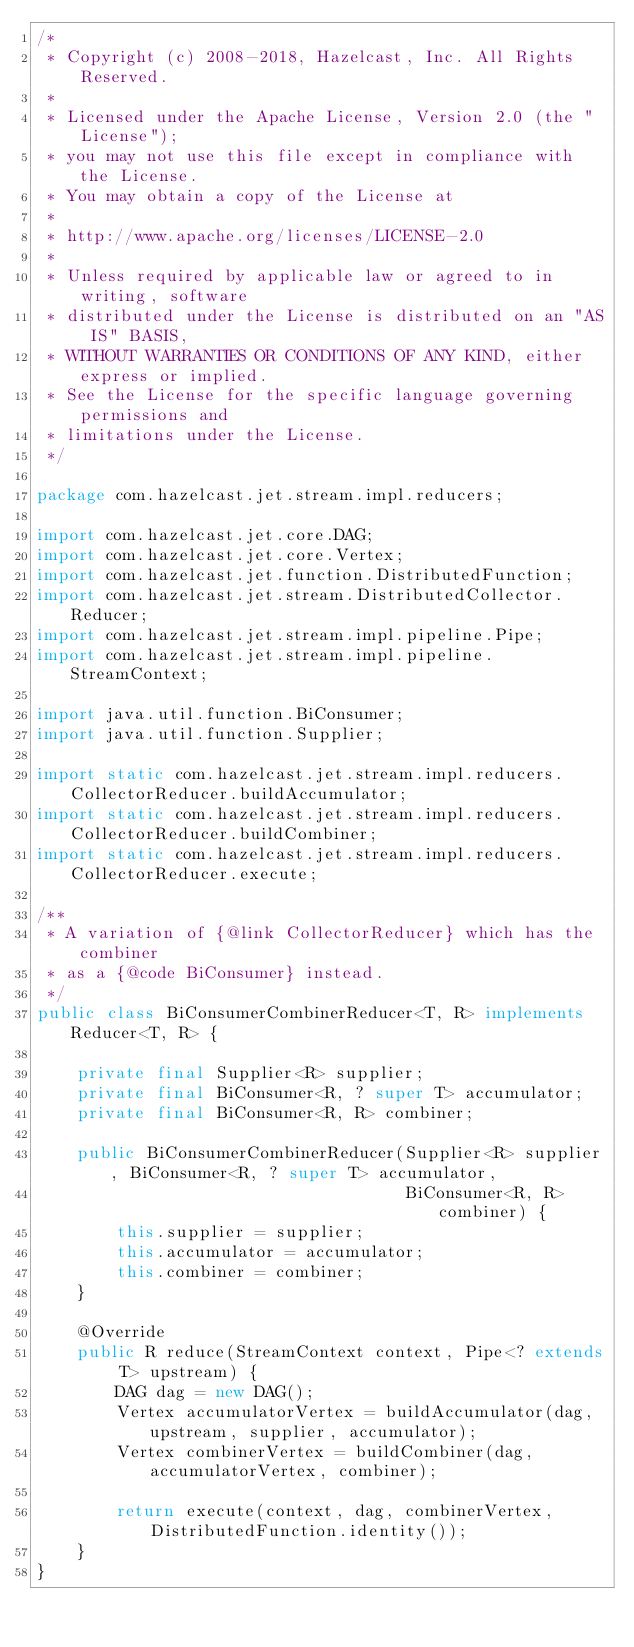Convert code to text. <code><loc_0><loc_0><loc_500><loc_500><_Java_>/*
 * Copyright (c) 2008-2018, Hazelcast, Inc. All Rights Reserved.
 *
 * Licensed under the Apache License, Version 2.0 (the "License");
 * you may not use this file except in compliance with the License.
 * You may obtain a copy of the License at
 *
 * http://www.apache.org/licenses/LICENSE-2.0
 *
 * Unless required by applicable law or agreed to in writing, software
 * distributed under the License is distributed on an "AS IS" BASIS,
 * WITHOUT WARRANTIES OR CONDITIONS OF ANY KIND, either express or implied.
 * See the License for the specific language governing permissions and
 * limitations under the License.
 */

package com.hazelcast.jet.stream.impl.reducers;

import com.hazelcast.jet.core.DAG;
import com.hazelcast.jet.core.Vertex;
import com.hazelcast.jet.function.DistributedFunction;
import com.hazelcast.jet.stream.DistributedCollector.Reducer;
import com.hazelcast.jet.stream.impl.pipeline.Pipe;
import com.hazelcast.jet.stream.impl.pipeline.StreamContext;

import java.util.function.BiConsumer;
import java.util.function.Supplier;

import static com.hazelcast.jet.stream.impl.reducers.CollectorReducer.buildAccumulator;
import static com.hazelcast.jet.stream.impl.reducers.CollectorReducer.buildCombiner;
import static com.hazelcast.jet.stream.impl.reducers.CollectorReducer.execute;

/**
 * A variation of {@link CollectorReducer} which has the combiner
 * as a {@code BiConsumer} instead.
 */
public class BiConsumerCombinerReducer<T, R> implements Reducer<T, R> {

    private final Supplier<R> supplier;
    private final BiConsumer<R, ? super T> accumulator;
    private final BiConsumer<R, R> combiner;

    public BiConsumerCombinerReducer(Supplier<R> supplier, BiConsumer<R, ? super T> accumulator,
                                     BiConsumer<R, R> combiner) {
        this.supplier = supplier;
        this.accumulator = accumulator;
        this.combiner = combiner;
    }

    @Override
    public R reduce(StreamContext context, Pipe<? extends T> upstream) {
        DAG dag = new DAG();
        Vertex accumulatorVertex = buildAccumulator(dag, upstream, supplier, accumulator);
        Vertex combinerVertex = buildCombiner(dag, accumulatorVertex, combiner);

        return execute(context, dag, combinerVertex, DistributedFunction.identity());
    }
}
</code> 